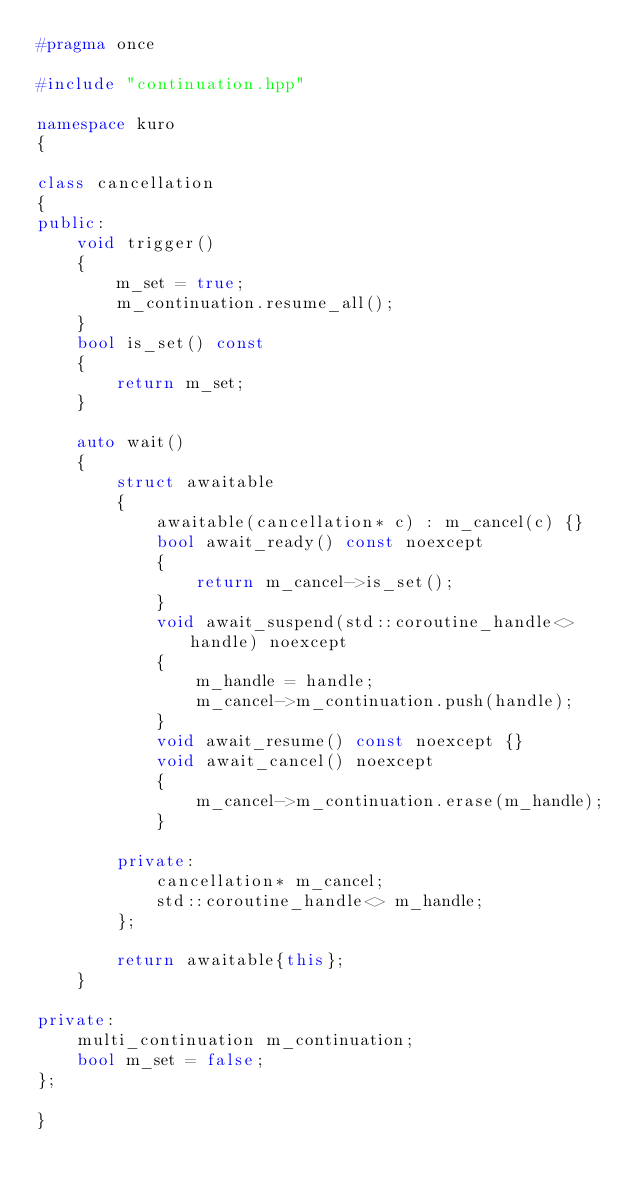<code> <loc_0><loc_0><loc_500><loc_500><_C++_>#pragma once

#include "continuation.hpp"

namespace kuro
{

class cancellation
{
public:
    void trigger()
    {
        m_set = true;
        m_continuation.resume_all();
    }
    bool is_set() const
    {
        return m_set;
    }

    auto wait()
    {
        struct awaitable
        {
            awaitable(cancellation* c) : m_cancel(c) {}
            bool await_ready() const noexcept
            {
                return m_cancel->is_set();
            }
            void await_suspend(std::coroutine_handle<> handle) noexcept
            {
                m_handle = handle;
                m_cancel->m_continuation.push(handle);
            }
            void await_resume() const noexcept {}
            void await_cancel() noexcept
            {
                m_cancel->m_continuation.erase(m_handle);
            }
        
        private:
            cancellation* m_cancel;
            std::coroutine_handle<> m_handle;
        };

        return awaitable{this};
    }

private:
    multi_continuation m_continuation;
    bool m_set = false;
};

}</code> 